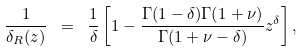<formula> <loc_0><loc_0><loc_500><loc_500>\frac { 1 } { \delta _ { R } ( z ) } \ = \ \frac { 1 } { \delta } \left [ 1 - \frac { \Gamma ( 1 - \delta ) \Gamma ( 1 + \nu ) } { \Gamma ( 1 + \nu - \delta ) } z ^ { \delta } \right ] ,</formula> 